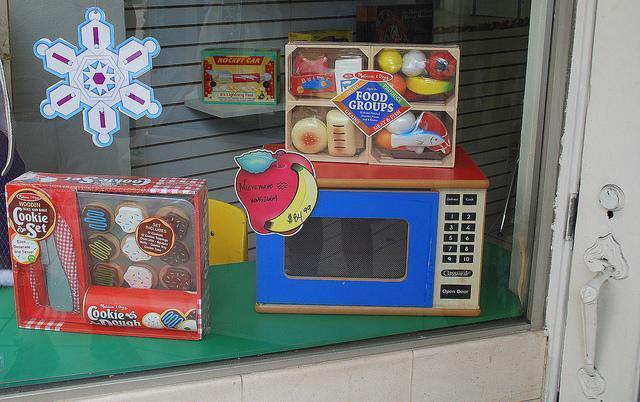How many toys are behind the window?
Give a very brief answer. 4. 